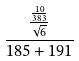<formula> <loc_0><loc_0><loc_500><loc_500>\frac { \frac { \frac { 1 0 } { 3 8 3 } } { \sqrt { 6 } } } { 1 8 5 + 1 9 1 }</formula> 